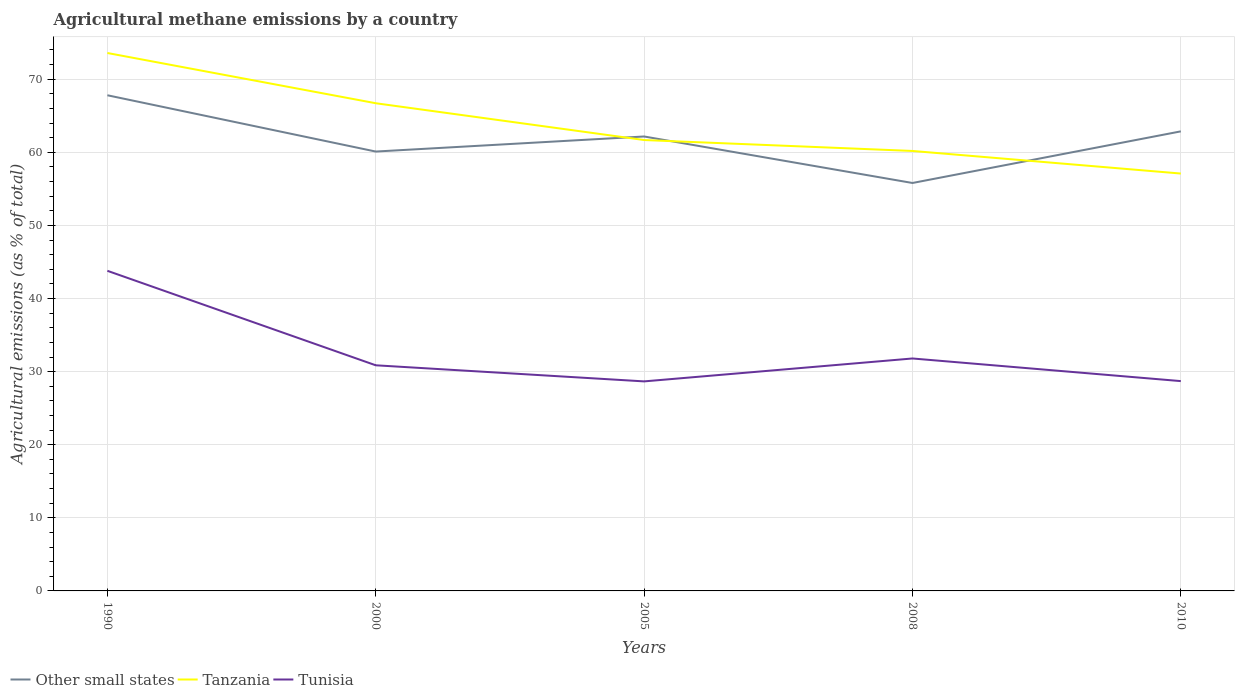How many different coloured lines are there?
Provide a succinct answer. 3. Across all years, what is the maximum amount of agricultural methane emitted in Other small states?
Make the answer very short. 55.81. In which year was the amount of agricultural methane emitted in Tunisia maximum?
Ensure brevity in your answer.  2005. What is the total amount of agricultural methane emitted in Other small states in the graph?
Keep it short and to the point. -2.06. What is the difference between the highest and the second highest amount of agricultural methane emitted in Tanzania?
Your answer should be very brief. 16.49. Is the amount of agricultural methane emitted in Tunisia strictly greater than the amount of agricultural methane emitted in Tanzania over the years?
Your response must be concise. Yes. How many years are there in the graph?
Provide a short and direct response. 5. What is the difference between two consecutive major ticks on the Y-axis?
Provide a short and direct response. 10. Does the graph contain any zero values?
Give a very brief answer. No. Does the graph contain grids?
Provide a short and direct response. Yes. How many legend labels are there?
Offer a very short reply. 3. What is the title of the graph?
Make the answer very short. Agricultural methane emissions by a country. Does "Greenland" appear as one of the legend labels in the graph?
Your response must be concise. No. What is the label or title of the X-axis?
Provide a short and direct response. Years. What is the label or title of the Y-axis?
Make the answer very short. Agricultural emissions (as % of total). What is the Agricultural emissions (as % of total) of Other small states in 1990?
Keep it short and to the point. 67.81. What is the Agricultural emissions (as % of total) in Tanzania in 1990?
Your answer should be compact. 73.59. What is the Agricultural emissions (as % of total) of Tunisia in 1990?
Offer a very short reply. 43.79. What is the Agricultural emissions (as % of total) in Other small states in 2000?
Ensure brevity in your answer.  60.11. What is the Agricultural emissions (as % of total) of Tanzania in 2000?
Make the answer very short. 66.72. What is the Agricultural emissions (as % of total) in Tunisia in 2000?
Offer a terse response. 30.87. What is the Agricultural emissions (as % of total) in Other small states in 2005?
Provide a short and direct response. 62.17. What is the Agricultural emissions (as % of total) in Tanzania in 2005?
Your answer should be very brief. 61.68. What is the Agricultural emissions (as % of total) of Tunisia in 2005?
Keep it short and to the point. 28.66. What is the Agricultural emissions (as % of total) in Other small states in 2008?
Offer a very short reply. 55.81. What is the Agricultural emissions (as % of total) of Tanzania in 2008?
Ensure brevity in your answer.  60.19. What is the Agricultural emissions (as % of total) of Tunisia in 2008?
Offer a very short reply. 31.8. What is the Agricultural emissions (as % of total) of Other small states in 2010?
Offer a terse response. 62.87. What is the Agricultural emissions (as % of total) in Tanzania in 2010?
Your response must be concise. 57.1. What is the Agricultural emissions (as % of total) in Tunisia in 2010?
Your answer should be compact. 28.7. Across all years, what is the maximum Agricultural emissions (as % of total) in Other small states?
Offer a very short reply. 67.81. Across all years, what is the maximum Agricultural emissions (as % of total) in Tanzania?
Give a very brief answer. 73.59. Across all years, what is the maximum Agricultural emissions (as % of total) in Tunisia?
Make the answer very short. 43.79. Across all years, what is the minimum Agricultural emissions (as % of total) of Other small states?
Your response must be concise. 55.81. Across all years, what is the minimum Agricultural emissions (as % of total) in Tanzania?
Keep it short and to the point. 57.1. Across all years, what is the minimum Agricultural emissions (as % of total) of Tunisia?
Keep it short and to the point. 28.66. What is the total Agricultural emissions (as % of total) in Other small states in the graph?
Provide a succinct answer. 308.76. What is the total Agricultural emissions (as % of total) in Tanzania in the graph?
Provide a short and direct response. 319.27. What is the total Agricultural emissions (as % of total) of Tunisia in the graph?
Provide a short and direct response. 163.82. What is the difference between the Agricultural emissions (as % of total) of Other small states in 1990 and that in 2000?
Give a very brief answer. 7.7. What is the difference between the Agricultural emissions (as % of total) in Tanzania in 1990 and that in 2000?
Your answer should be compact. 6.87. What is the difference between the Agricultural emissions (as % of total) in Tunisia in 1990 and that in 2000?
Your answer should be very brief. 12.93. What is the difference between the Agricultural emissions (as % of total) in Other small states in 1990 and that in 2005?
Provide a succinct answer. 5.64. What is the difference between the Agricultural emissions (as % of total) of Tanzania in 1990 and that in 2005?
Your response must be concise. 11.91. What is the difference between the Agricultural emissions (as % of total) in Tunisia in 1990 and that in 2005?
Provide a succinct answer. 15.13. What is the difference between the Agricultural emissions (as % of total) of Other small states in 1990 and that in 2008?
Give a very brief answer. 12. What is the difference between the Agricultural emissions (as % of total) in Tanzania in 1990 and that in 2008?
Give a very brief answer. 13.4. What is the difference between the Agricultural emissions (as % of total) in Tunisia in 1990 and that in 2008?
Ensure brevity in your answer.  11.99. What is the difference between the Agricultural emissions (as % of total) in Other small states in 1990 and that in 2010?
Ensure brevity in your answer.  4.94. What is the difference between the Agricultural emissions (as % of total) in Tanzania in 1990 and that in 2010?
Offer a very short reply. 16.49. What is the difference between the Agricultural emissions (as % of total) of Tunisia in 1990 and that in 2010?
Provide a succinct answer. 15.09. What is the difference between the Agricultural emissions (as % of total) in Other small states in 2000 and that in 2005?
Make the answer very short. -2.06. What is the difference between the Agricultural emissions (as % of total) in Tanzania in 2000 and that in 2005?
Offer a terse response. 5.03. What is the difference between the Agricultural emissions (as % of total) in Tunisia in 2000 and that in 2005?
Provide a short and direct response. 2.2. What is the difference between the Agricultural emissions (as % of total) in Other small states in 2000 and that in 2008?
Make the answer very short. 4.3. What is the difference between the Agricultural emissions (as % of total) of Tanzania in 2000 and that in 2008?
Your answer should be compact. 6.53. What is the difference between the Agricultural emissions (as % of total) in Tunisia in 2000 and that in 2008?
Provide a short and direct response. -0.93. What is the difference between the Agricultural emissions (as % of total) in Other small states in 2000 and that in 2010?
Give a very brief answer. -2.76. What is the difference between the Agricultural emissions (as % of total) of Tanzania in 2000 and that in 2010?
Offer a very short reply. 9.62. What is the difference between the Agricultural emissions (as % of total) of Tunisia in 2000 and that in 2010?
Give a very brief answer. 2.16. What is the difference between the Agricultural emissions (as % of total) of Other small states in 2005 and that in 2008?
Make the answer very short. 6.36. What is the difference between the Agricultural emissions (as % of total) of Tanzania in 2005 and that in 2008?
Your answer should be very brief. 1.49. What is the difference between the Agricultural emissions (as % of total) in Tunisia in 2005 and that in 2008?
Keep it short and to the point. -3.14. What is the difference between the Agricultural emissions (as % of total) of Other small states in 2005 and that in 2010?
Provide a succinct answer. -0.7. What is the difference between the Agricultural emissions (as % of total) in Tanzania in 2005 and that in 2010?
Ensure brevity in your answer.  4.59. What is the difference between the Agricultural emissions (as % of total) in Tunisia in 2005 and that in 2010?
Keep it short and to the point. -0.04. What is the difference between the Agricultural emissions (as % of total) of Other small states in 2008 and that in 2010?
Give a very brief answer. -7.06. What is the difference between the Agricultural emissions (as % of total) in Tanzania in 2008 and that in 2010?
Your answer should be compact. 3.09. What is the difference between the Agricultural emissions (as % of total) of Tunisia in 2008 and that in 2010?
Ensure brevity in your answer.  3.1. What is the difference between the Agricultural emissions (as % of total) in Other small states in 1990 and the Agricultural emissions (as % of total) in Tanzania in 2000?
Keep it short and to the point. 1.09. What is the difference between the Agricultural emissions (as % of total) of Other small states in 1990 and the Agricultural emissions (as % of total) of Tunisia in 2000?
Your answer should be very brief. 36.94. What is the difference between the Agricultural emissions (as % of total) in Tanzania in 1990 and the Agricultural emissions (as % of total) in Tunisia in 2000?
Give a very brief answer. 42.72. What is the difference between the Agricultural emissions (as % of total) in Other small states in 1990 and the Agricultural emissions (as % of total) in Tanzania in 2005?
Your response must be concise. 6.13. What is the difference between the Agricultural emissions (as % of total) in Other small states in 1990 and the Agricultural emissions (as % of total) in Tunisia in 2005?
Give a very brief answer. 39.14. What is the difference between the Agricultural emissions (as % of total) in Tanzania in 1990 and the Agricultural emissions (as % of total) in Tunisia in 2005?
Your response must be concise. 44.93. What is the difference between the Agricultural emissions (as % of total) of Other small states in 1990 and the Agricultural emissions (as % of total) of Tanzania in 2008?
Offer a terse response. 7.62. What is the difference between the Agricultural emissions (as % of total) of Other small states in 1990 and the Agricultural emissions (as % of total) of Tunisia in 2008?
Provide a succinct answer. 36.01. What is the difference between the Agricultural emissions (as % of total) of Tanzania in 1990 and the Agricultural emissions (as % of total) of Tunisia in 2008?
Provide a succinct answer. 41.79. What is the difference between the Agricultural emissions (as % of total) of Other small states in 1990 and the Agricultural emissions (as % of total) of Tanzania in 2010?
Your answer should be compact. 10.71. What is the difference between the Agricultural emissions (as % of total) of Other small states in 1990 and the Agricultural emissions (as % of total) of Tunisia in 2010?
Provide a short and direct response. 39.11. What is the difference between the Agricultural emissions (as % of total) of Tanzania in 1990 and the Agricultural emissions (as % of total) of Tunisia in 2010?
Give a very brief answer. 44.89. What is the difference between the Agricultural emissions (as % of total) in Other small states in 2000 and the Agricultural emissions (as % of total) in Tanzania in 2005?
Your response must be concise. -1.58. What is the difference between the Agricultural emissions (as % of total) in Other small states in 2000 and the Agricultural emissions (as % of total) in Tunisia in 2005?
Give a very brief answer. 31.44. What is the difference between the Agricultural emissions (as % of total) of Tanzania in 2000 and the Agricultural emissions (as % of total) of Tunisia in 2005?
Your answer should be compact. 38.05. What is the difference between the Agricultural emissions (as % of total) of Other small states in 2000 and the Agricultural emissions (as % of total) of Tanzania in 2008?
Provide a succinct answer. -0.08. What is the difference between the Agricultural emissions (as % of total) of Other small states in 2000 and the Agricultural emissions (as % of total) of Tunisia in 2008?
Your response must be concise. 28.31. What is the difference between the Agricultural emissions (as % of total) in Tanzania in 2000 and the Agricultural emissions (as % of total) in Tunisia in 2008?
Give a very brief answer. 34.92. What is the difference between the Agricultural emissions (as % of total) in Other small states in 2000 and the Agricultural emissions (as % of total) in Tanzania in 2010?
Your answer should be very brief. 3.01. What is the difference between the Agricultural emissions (as % of total) in Other small states in 2000 and the Agricultural emissions (as % of total) in Tunisia in 2010?
Give a very brief answer. 31.4. What is the difference between the Agricultural emissions (as % of total) of Tanzania in 2000 and the Agricultural emissions (as % of total) of Tunisia in 2010?
Provide a short and direct response. 38.01. What is the difference between the Agricultural emissions (as % of total) in Other small states in 2005 and the Agricultural emissions (as % of total) in Tanzania in 2008?
Your response must be concise. 1.98. What is the difference between the Agricultural emissions (as % of total) of Other small states in 2005 and the Agricultural emissions (as % of total) of Tunisia in 2008?
Keep it short and to the point. 30.37. What is the difference between the Agricultural emissions (as % of total) in Tanzania in 2005 and the Agricultural emissions (as % of total) in Tunisia in 2008?
Your answer should be very brief. 29.88. What is the difference between the Agricultural emissions (as % of total) in Other small states in 2005 and the Agricultural emissions (as % of total) in Tanzania in 2010?
Provide a succinct answer. 5.07. What is the difference between the Agricultural emissions (as % of total) in Other small states in 2005 and the Agricultural emissions (as % of total) in Tunisia in 2010?
Your response must be concise. 33.47. What is the difference between the Agricultural emissions (as % of total) of Tanzania in 2005 and the Agricultural emissions (as % of total) of Tunisia in 2010?
Offer a terse response. 32.98. What is the difference between the Agricultural emissions (as % of total) of Other small states in 2008 and the Agricultural emissions (as % of total) of Tanzania in 2010?
Offer a terse response. -1.29. What is the difference between the Agricultural emissions (as % of total) of Other small states in 2008 and the Agricultural emissions (as % of total) of Tunisia in 2010?
Provide a short and direct response. 27.1. What is the difference between the Agricultural emissions (as % of total) in Tanzania in 2008 and the Agricultural emissions (as % of total) in Tunisia in 2010?
Provide a succinct answer. 31.49. What is the average Agricultural emissions (as % of total) of Other small states per year?
Keep it short and to the point. 61.75. What is the average Agricultural emissions (as % of total) in Tanzania per year?
Offer a very short reply. 63.85. What is the average Agricultural emissions (as % of total) of Tunisia per year?
Make the answer very short. 32.76. In the year 1990, what is the difference between the Agricultural emissions (as % of total) in Other small states and Agricultural emissions (as % of total) in Tanzania?
Make the answer very short. -5.78. In the year 1990, what is the difference between the Agricultural emissions (as % of total) in Other small states and Agricultural emissions (as % of total) in Tunisia?
Offer a very short reply. 24.02. In the year 1990, what is the difference between the Agricultural emissions (as % of total) in Tanzania and Agricultural emissions (as % of total) in Tunisia?
Provide a short and direct response. 29.8. In the year 2000, what is the difference between the Agricultural emissions (as % of total) in Other small states and Agricultural emissions (as % of total) in Tanzania?
Ensure brevity in your answer.  -6.61. In the year 2000, what is the difference between the Agricultural emissions (as % of total) in Other small states and Agricultural emissions (as % of total) in Tunisia?
Ensure brevity in your answer.  29.24. In the year 2000, what is the difference between the Agricultural emissions (as % of total) of Tanzania and Agricultural emissions (as % of total) of Tunisia?
Provide a succinct answer. 35.85. In the year 2005, what is the difference between the Agricultural emissions (as % of total) of Other small states and Agricultural emissions (as % of total) of Tanzania?
Your answer should be very brief. 0.48. In the year 2005, what is the difference between the Agricultural emissions (as % of total) in Other small states and Agricultural emissions (as % of total) in Tunisia?
Give a very brief answer. 33.5. In the year 2005, what is the difference between the Agricultural emissions (as % of total) in Tanzania and Agricultural emissions (as % of total) in Tunisia?
Your response must be concise. 33.02. In the year 2008, what is the difference between the Agricultural emissions (as % of total) in Other small states and Agricultural emissions (as % of total) in Tanzania?
Your answer should be compact. -4.38. In the year 2008, what is the difference between the Agricultural emissions (as % of total) of Other small states and Agricultural emissions (as % of total) of Tunisia?
Ensure brevity in your answer.  24.01. In the year 2008, what is the difference between the Agricultural emissions (as % of total) in Tanzania and Agricultural emissions (as % of total) in Tunisia?
Make the answer very short. 28.39. In the year 2010, what is the difference between the Agricultural emissions (as % of total) of Other small states and Agricultural emissions (as % of total) of Tanzania?
Offer a terse response. 5.77. In the year 2010, what is the difference between the Agricultural emissions (as % of total) of Other small states and Agricultural emissions (as % of total) of Tunisia?
Make the answer very short. 34.17. In the year 2010, what is the difference between the Agricultural emissions (as % of total) of Tanzania and Agricultural emissions (as % of total) of Tunisia?
Give a very brief answer. 28.4. What is the ratio of the Agricultural emissions (as % of total) in Other small states in 1990 to that in 2000?
Your response must be concise. 1.13. What is the ratio of the Agricultural emissions (as % of total) of Tanzania in 1990 to that in 2000?
Your answer should be compact. 1.1. What is the ratio of the Agricultural emissions (as % of total) in Tunisia in 1990 to that in 2000?
Provide a short and direct response. 1.42. What is the ratio of the Agricultural emissions (as % of total) in Other small states in 1990 to that in 2005?
Your answer should be very brief. 1.09. What is the ratio of the Agricultural emissions (as % of total) of Tanzania in 1990 to that in 2005?
Keep it short and to the point. 1.19. What is the ratio of the Agricultural emissions (as % of total) of Tunisia in 1990 to that in 2005?
Keep it short and to the point. 1.53. What is the ratio of the Agricultural emissions (as % of total) in Other small states in 1990 to that in 2008?
Your answer should be compact. 1.22. What is the ratio of the Agricultural emissions (as % of total) of Tanzania in 1990 to that in 2008?
Offer a terse response. 1.22. What is the ratio of the Agricultural emissions (as % of total) in Tunisia in 1990 to that in 2008?
Ensure brevity in your answer.  1.38. What is the ratio of the Agricultural emissions (as % of total) of Other small states in 1990 to that in 2010?
Provide a short and direct response. 1.08. What is the ratio of the Agricultural emissions (as % of total) of Tanzania in 1990 to that in 2010?
Your response must be concise. 1.29. What is the ratio of the Agricultural emissions (as % of total) of Tunisia in 1990 to that in 2010?
Your answer should be compact. 1.53. What is the ratio of the Agricultural emissions (as % of total) of Other small states in 2000 to that in 2005?
Offer a very short reply. 0.97. What is the ratio of the Agricultural emissions (as % of total) in Tanzania in 2000 to that in 2005?
Give a very brief answer. 1.08. What is the ratio of the Agricultural emissions (as % of total) of Tunisia in 2000 to that in 2005?
Keep it short and to the point. 1.08. What is the ratio of the Agricultural emissions (as % of total) of Other small states in 2000 to that in 2008?
Your answer should be very brief. 1.08. What is the ratio of the Agricultural emissions (as % of total) of Tanzania in 2000 to that in 2008?
Make the answer very short. 1.11. What is the ratio of the Agricultural emissions (as % of total) of Tunisia in 2000 to that in 2008?
Keep it short and to the point. 0.97. What is the ratio of the Agricultural emissions (as % of total) in Other small states in 2000 to that in 2010?
Give a very brief answer. 0.96. What is the ratio of the Agricultural emissions (as % of total) of Tanzania in 2000 to that in 2010?
Provide a succinct answer. 1.17. What is the ratio of the Agricultural emissions (as % of total) in Tunisia in 2000 to that in 2010?
Your answer should be compact. 1.08. What is the ratio of the Agricultural emissions (as % of total) in Other small states in 2005 to that in 2008?
Provide a succinct answer. 1.11. What is the ratio of the Agricultural emissions (as % of total) of Tanzania in 2005 to that in 2008?
Give a very brief answer. 1.02. What is the ratio of the Agricultural emissions (as % of total) of Tunisia in 2005 to that in 2008?
Offer a terse response. 0.9. What is the ratio of the Agricultural emissions (as % of total) in Other small states in 2005 to that in 2010?
Offer a terse response. 0.99. What is the ratio of the Agricultural emissions (as % of total) in Tanzania in 2005 to that in 2010?
Provide a short and direct response. 1.08. What is the ratio of the Agricultural emissions (as % of total) in Tunisia in 2005 to that in 2010?
Offer a very short reply. 1. What is the ratio of the Agricultural emissions (as % of total) of Other small states in 2008 to that in 2010?
Your answer should be very brief. 0.89. What is the ratio of the Agricultural emissions (as % of total) of Tanzania in 2008 to that in 2010?
Your answer should be very brief. 1.05. What is the ratio of the Agricultural emissions (as % of total) of Tunisia in 2008 to that in 2010?
Keep it short and to the point. 1.11. What is the difference between the highest and the second highest Agricultural emissions (as % of total) of Other small states?
Keep it short and to the point. 4.94. What is the difference between the highest and the second highest Agricultural emissions (as % of total) of Tanzania?
Your response must be concise. 6.87. What is the difference between the highest and the second highest Agricultural emissions (as % of total) in Tunisia?
Your answer should be very brief. 11.99. What is the difference between the highest and the lowest Agricultural emissions (as % of total) of Other small states?
Provide a succinct answer. 12. What is the difference between the highest and the lowest Agricultural emissions (as % of total) of Tanzania?
Ensure brevity in your answer.  16.49. What is the difference between the highest and the lowest Agricultural emissions (as % of total) in Tunisia?
Your answer should be very brief. 15.13. 